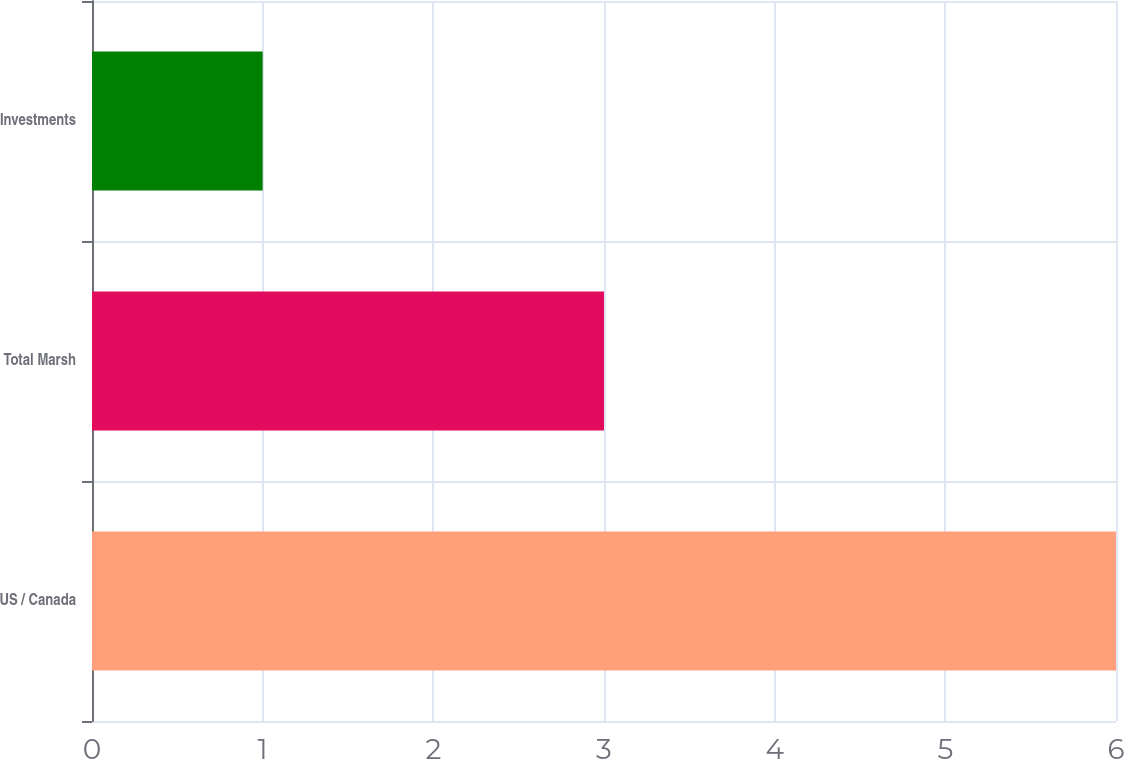Convert chart to OTSL. <chart><loc_0><loc_0><loc_500><loc_500><bar_chart><fcel>US / Canada<fcel>Total Marsh<fcel>Investments<nl><fcel>6<fcel>3<fcel>1<nl></chart> 